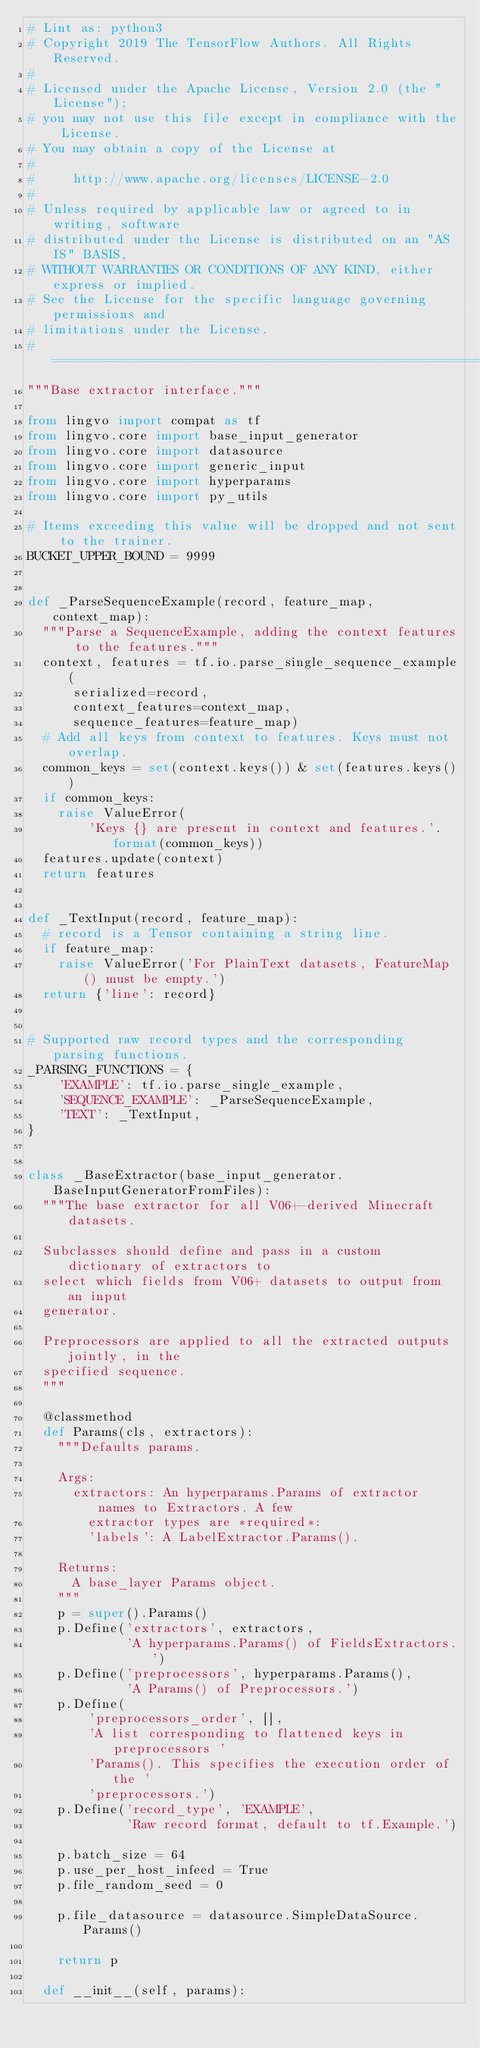<code> <loc_0><loc_0><loc_500><loc_500><_Python_># Lint as: python3
# Copyright 2019 The TensorFlow Authors. All Rights Reserved.
#
# Licensed under the Apache License, Version 2.0 (the "License");
# you may not use this file except in compliance with the License.
# You may obtain a copy of the License at
#
#     http://www.apache.org/licenses/LICENSE-2.0
#
# Unless required by applicable law or agreed to in writing, software
# distributed under the License is distributed on an "AS IS" BASIS,
# WITHOUT WARRANTIES OR CONDITIONS OF ANY KIND, either express or implied.
# See the License for the specific language governing permissions and
# limitations under the License.
# ==============================================================================
"""Base extractor interface."""

from lingvo import compat as tf
from lingvo.core import base_input_generator
from lingvo.core import datasource
from lingvo.core import generic_input
from lingvo.core import hyperparams
from lingvo.core import py_utils

# Items exceeding this value will be dropped and not sent to the trainer.
BUCKET_UPPER_BOUND = 9999


def _ParseSequenceExample(record, feature_map, context_map):
  """Parse a SequenceExample, adding the context features to the features."""
  context, features = tf.io.parse_single_sequence_example(
      serialized=record,
      context_features=context_map,
      sequence_features=feature_map)
  # Add all keys from context to features. Keys must not overlap.
  common_keys = set(context.keys()) & set(features.keys())
  if common_keys:
    raise ValueError(
        'Keys {} are present in context and features.'.format(common_keys))
  features.update(context)
  return features


def _TextInput(record, feature_map):
  # record is a Tensor containing a string line.
  if feature_map:
    raise ValueError('For PlainText datasets, FeatureMap() must be empty.')
  return {'line': record}


# Supported raw record types and the corresponding parsing functions.
_PARSING_FUNCTIONS = {
    'EXAMPLE': tf.io.parse_single_example,
    'SEQUENCE_EXAMPLE': _ParseSequenceExample,
    'TEXT': _TextInput,
}


class _BaseExtractor(base_input_generator.BaseInputGeneratorFromFiles):
  """The base extractor for all V06+-derived Minecraft datasets.

  Subclasses should define and pass in a custom dictionary of extractors to
  select which fields from V06+ datasets to output from an input
  generator.

  Preprocessors are applied to all the extracted outputs jointly, in the
  specified sequence.
  """

  @classmethod
  def Params(cls, extractors):
    """Defaults params.

    Args:
      extractors: An hyperparams.Params of extractor names to Extractors. A few
        extractor types are *required*:
        'labels': A LabelExtractor.Params().

    Returns:
      A base_layer Params object.
    """
    p = super().Params()
    p.Define('extractors', extractors,
             'A hyperparams.Params() of FieldsExtractors.')
    p.Define('preprocessors', hyperparams.Params(),
             'A Params() of Preprocessors.')
    p.Define(
        'preprocessors_order', [],
        'A list corresponding to flattened keys in preprocessors '
        'Params(). This specifies the execution order of the '
        'preprocessors.')
    p.Define('record_type', 'EXAMPLE',
             'Raw record format, default to tf.Example.')

    p.batch_size = 64
    p.use_per_host_infeed = True
    p.file_random_seed = 0

    p.file_datasource = datasource.SimpleDataSource.Params()

    return p

  def __init__(self, params):</code> 